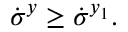Convert formula to latex. <formula><loc_0><loc_0><loc_500><loc_500>\dot { \sigma } ^ { y } \geq \dot { \sigma } ^ { y _ { 1 } } .</formula> 